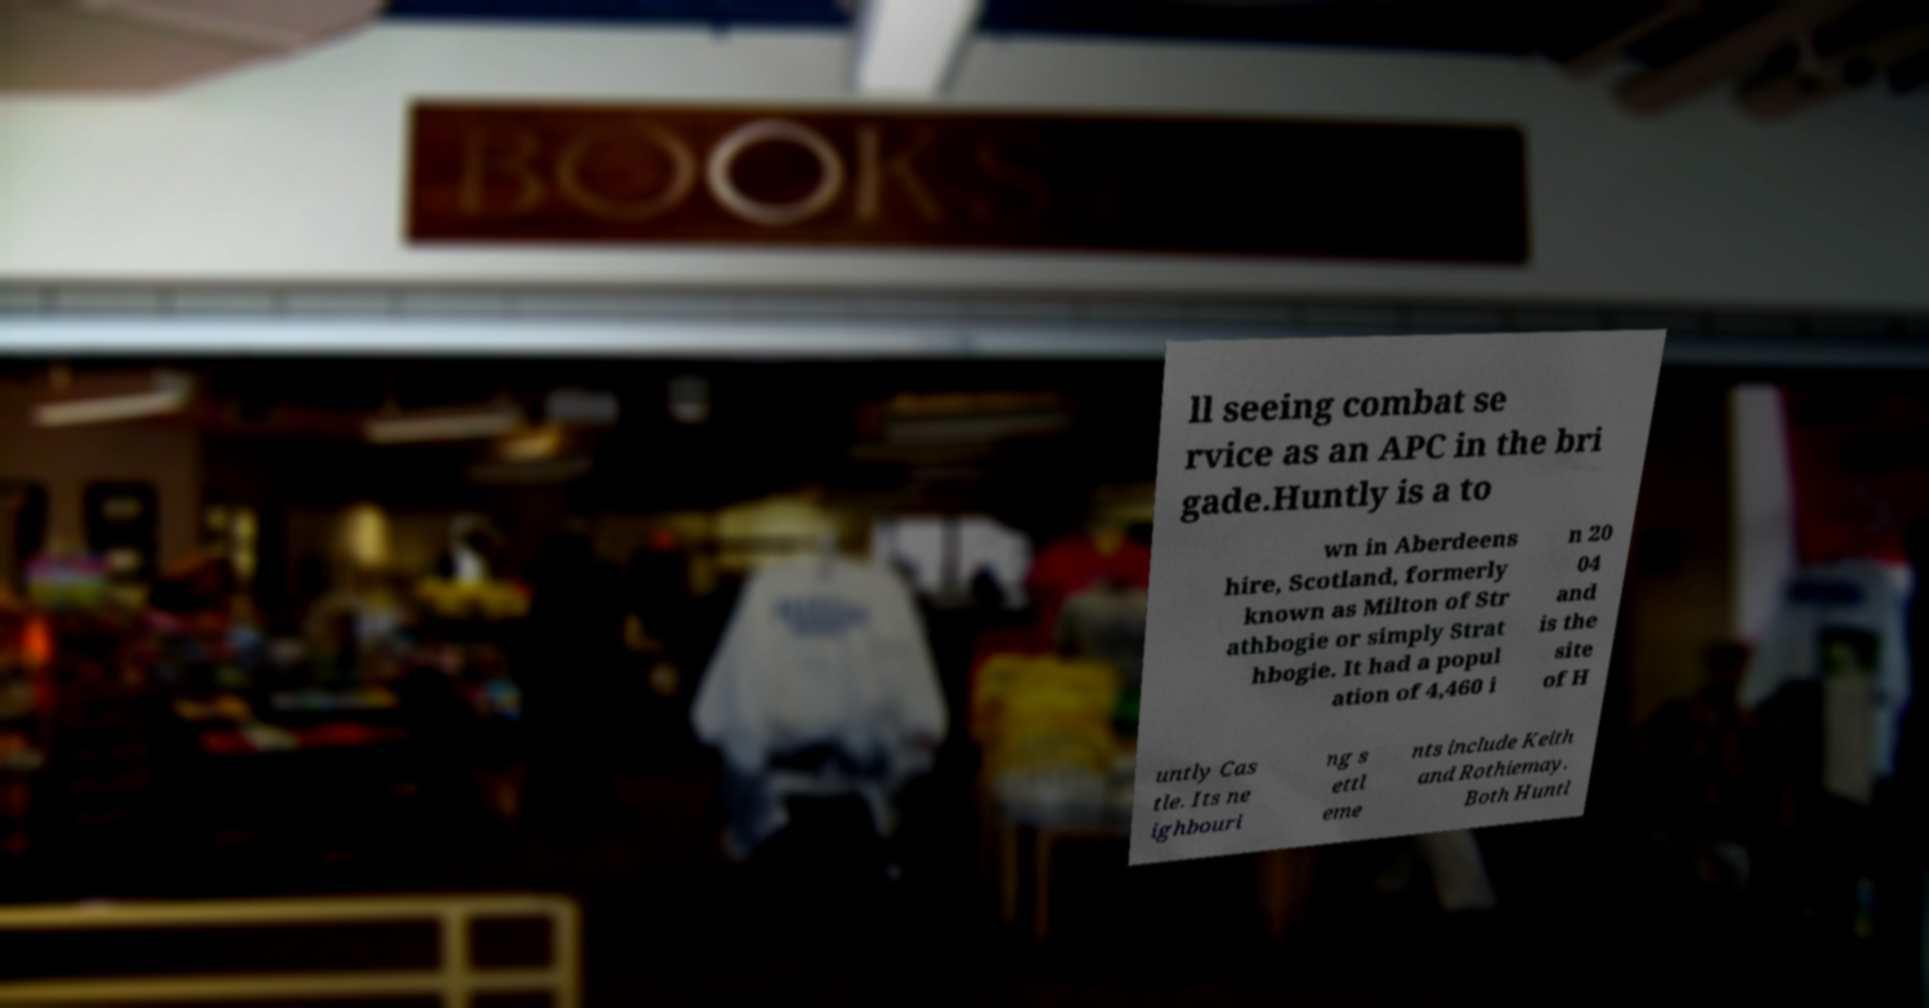There's text embedded in this image that I need extracted. Can you transcribe it verbatim? ll seeing combat se rvice as an APC in the bri gade.Huntly is a to wn in Aberdeens hire, Scotland, formerly known as Milton of Str athbogie or simply Strat hbogie. It had a popul ation of 4,460 i n 20 04 and is the site of H untly Cas tle. Its ne ighbouri ng s ettl eme nts include Keith and Rothiemay. Both Huntl 